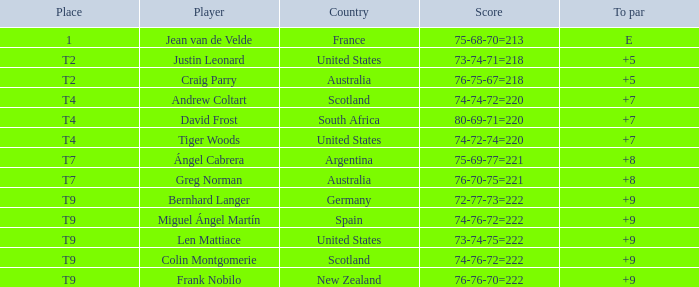In which position does a player with an 'e' to par score stand? 1.0. Could you help me parse every detail presented in this table? {'header': ['Place', 'Player', 'Country', 'Score', 'To par'], 'rows': [['1', 'Jean van de Velde', 'France', '75-68-70=213', 'E'], ['T2', 'Justin Leonard', 'United States', '73-74-71=218', '+5'], ['T2', 'Craig Parry', 'Australia', '76-75-67=218', '+5'], ['T4', 'Andrew Coltart', 'Scotland', '74-74-72=220', '+7'], ['T4', 'David Frost', 'South Africa', '80-69-71=220', '+7'], ['T4', 'Tiger Woods', 'United States', '74-72-74=220', '+7'], ['T7', 'Ángel Cabrera', 'Argentina', '75-69-77=221', '+8'], ['T7', 'Greg Norman', 'Australia', '76-70-75=221', '+8'], ['T9', 'Bernhard Langer', 'Germany', '72-77-73=222', '+9'], ['T9', 'Miguel Ángel Martín', 'Spain', '74-76-72=222', '+9'], ['T9', 'Len Mattiace', 'United States', '73-74-75=222', '+9'], ['T9', 'Colin Montgomerie', 'Scotland', '74-76-72=222', '+9'], ['T9', 'Frank Nobilo', 'New Zealand', '76-76-70=222', '+9']]} 